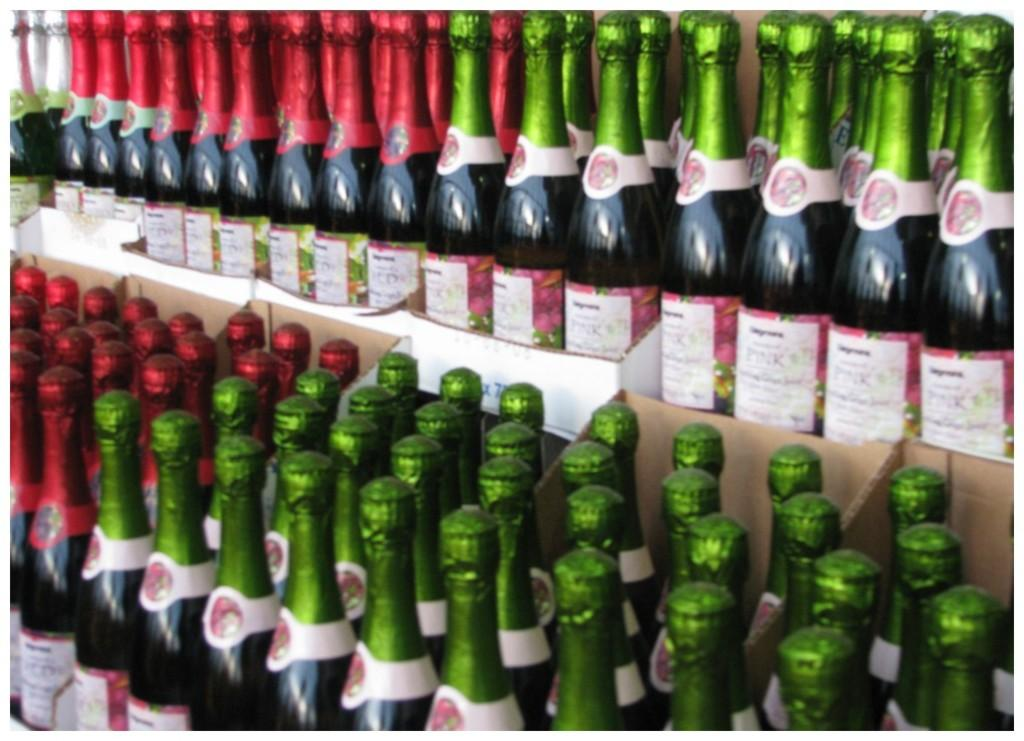<image>
Offer a succinct explanation of the picture presented. Several types of champagne with green and red foil, the one with green being Pink type champagne. 